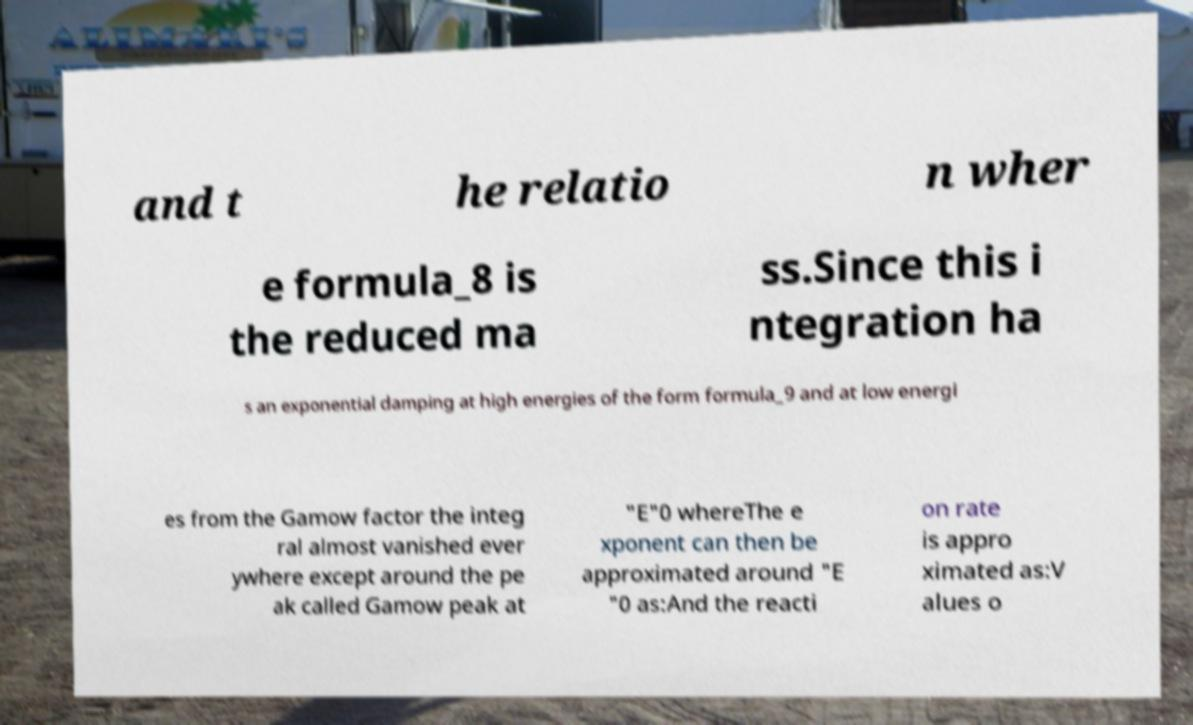Please identify and transcribe the text found in this image. and t he relatio n wher e formula_8 is the reduced ma ss.Since this i ntegration ha s an exponential damping at high energies of the form formula_9 and at low energi es from the Gamow factor the integ ral almost vanished ever ywhere except around the pe ak called Gamow peak at "E"0 whereThe e xponent can then be approximated around "E "0 as:And the reacti on rate is appro ximated as:V alues o 